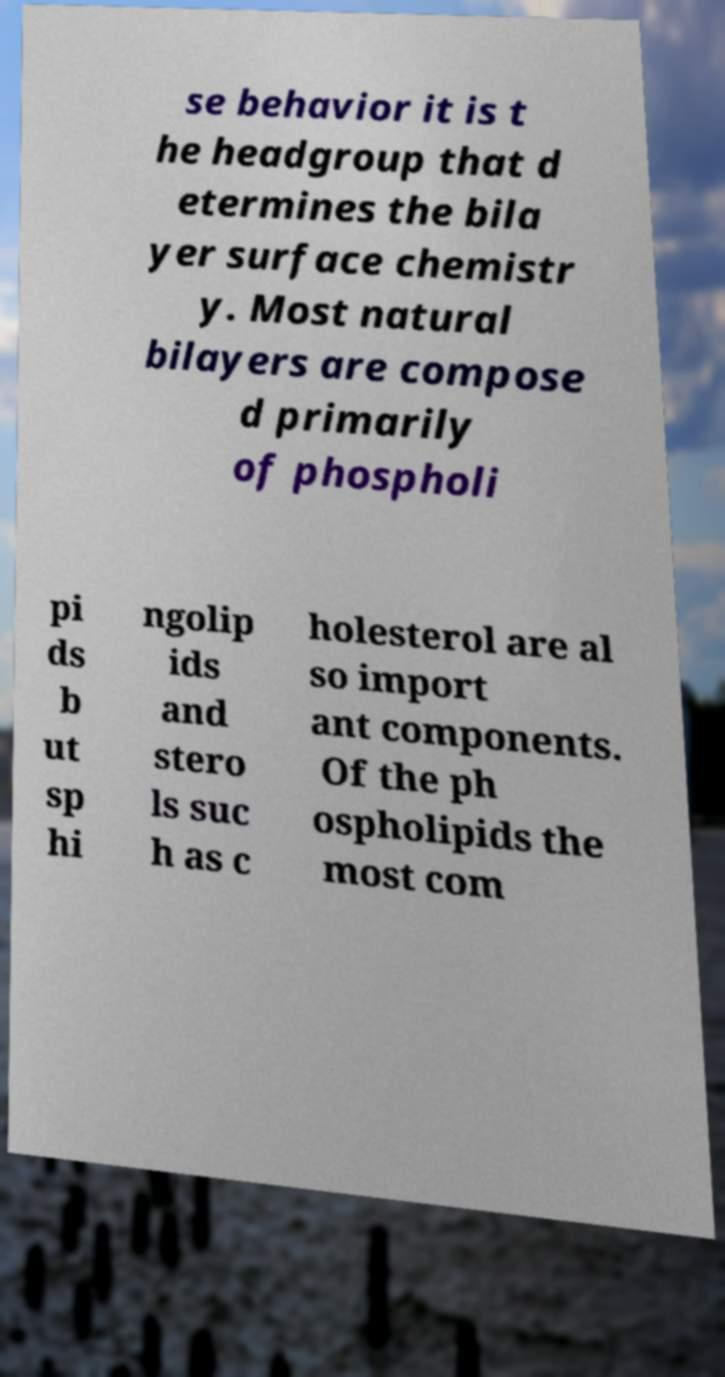Please identify and transcribe the text found in this image. se behavior it is t he headgroup that d etermines the bila yer surface chemistr y. Most natural bilayers are compose d primarily of phospholi pi ds b ut sp hi ngolip ids and stero ls suc h as c holesterol are al so import ant components. Of the ph ospholipids the most com 